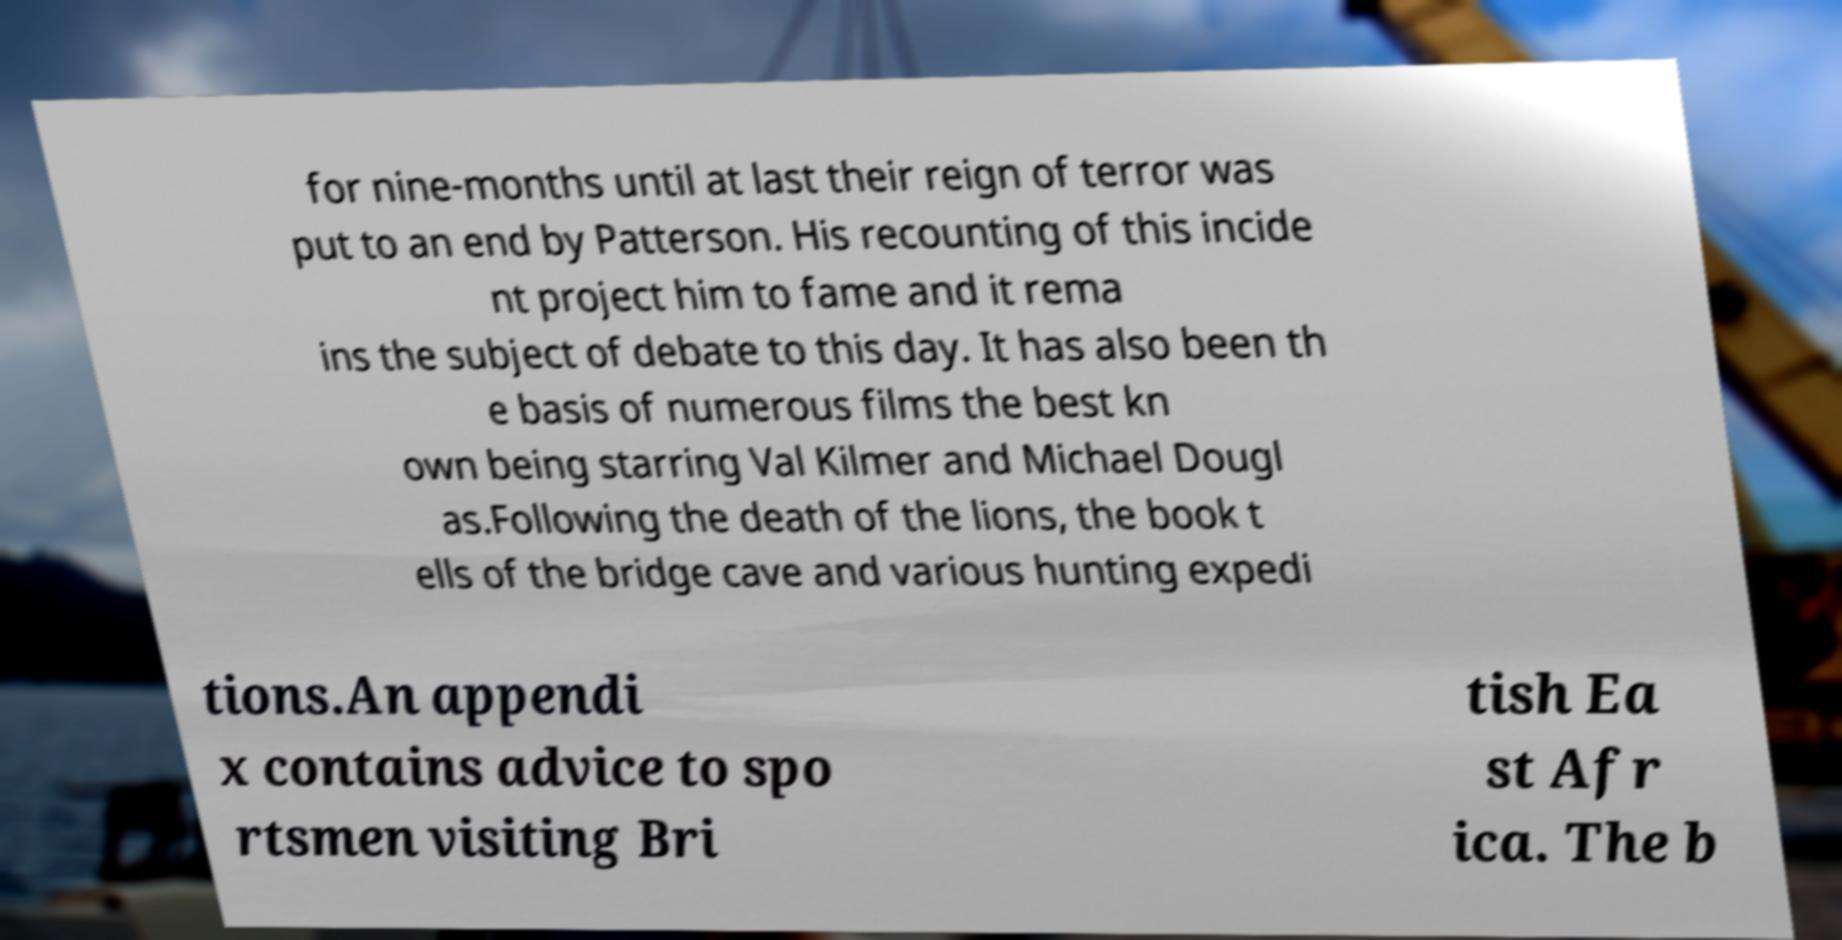Please read and relay the text visible in this image. What does it say? for nine-months until at last their reign of terror was put to an end by Patterson. His recounting of this incide nt project him to fame and it rema ins the subject of debate to this day. It has also been th e basis of numerous films the best kn own being starring Val Kilmer and Michael Dougl as.Following the death of the lions, the book t ells of the bridge cave and various hunting expedi tions.An appendi x contains advice to spo rtsmen visiting Bri tish Ea st Afr ica. The b 